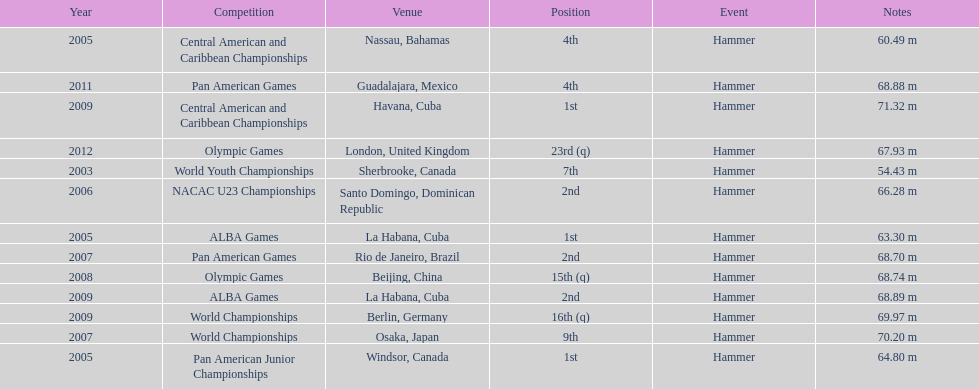How many times was the number one position earned? 3. Give me the full table as a dictionary. {'header': ['Year', 'Competition', 'Venue', 'Position', 'Event', 'Notes'], 'rows': [['2005', 'Central American and Caribbean Championships', 'Nassau, Bahamas', '4th', 'Hammer', '60.49 m'], ['2011', 'Pan American Games', 'Guadalajara, Mexico', '4th', 'Hammer', '68.88 m'], ['2009', 'Central American and Caribbean Championships', 'Havana, Cuba', '1st', 'Hammer', '71.32 m'], ['2012', 'Olympic Games', 'London, United Kingdom', '23rd (q)', 'Hammer', '67.93 m'], ['2003', 'World Youth Championships', 'Sherbrooke, Canada', '7th', 'Hammer', '54.43 m'], ['2006', 'NACAC U23 Championships', 'Santo Domingo, Dominican Republic', '2nd', 'Hammer', '66.28 m'], ['2005', 'ALBA Games', 'La Habana, Cuba', '1st', 'Hammer', '63.30 m'], ['2007', 'Pan American Games', 'Rio de Janeiro, Brazil', '2nd', 'Hammer', '68.70 m'], ['2008', 'Olympic Games', 'Beijing, China', '15th (q)', 'Hammer', '68.74 m'], ['2009', 'ALBA Games', 'La Habana, Cuba', '2nd', 'Hammer', '68.89 m'], ['2009', 'World Championships', 'Berlin, Germany', '16th (q)', 'Hammer', '69.97 m'], ['2007', 'World Championships', 'Osaka, Japan', '9th', 'Hammer', '70.20 m'], ['2005', 'Pan American Junior Championships', 'Windsor, Canada', '1st', 'Hammer', '64.80 m']]} 